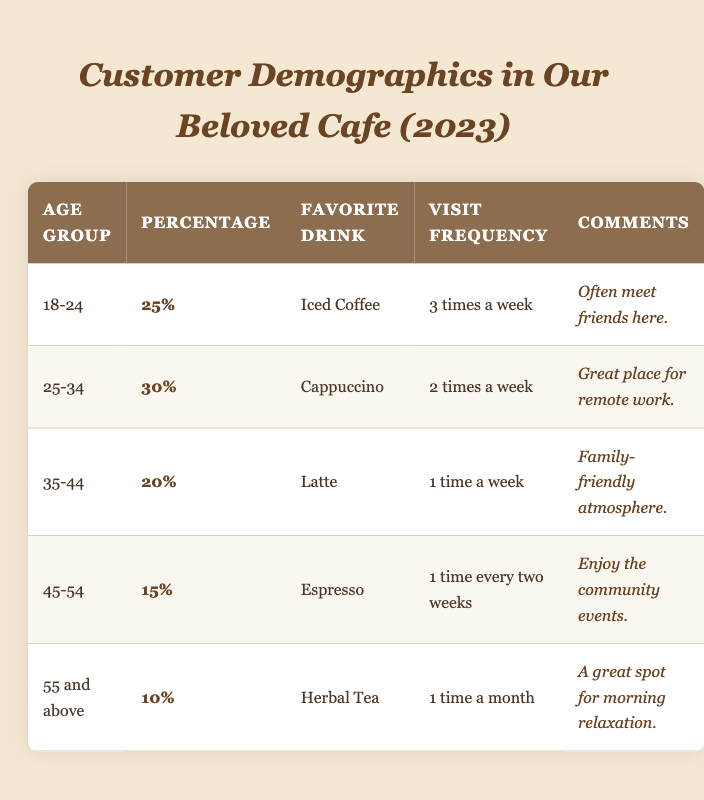What percentage of customers are aged 25-34? In the table, the entry for the age group 25-34 shows a percentage of 30%.
Answer: 30% Which age group visits the cafe most frequently? The age group 18-24 visits the cafe 3 times a week, which is more than any other group's frequency.
Answer: 18-24 What is the favorite drink of customers aged 55 and above? The table indicates that the favorite drink for the age group 55 and above is Herbal Tea.
Answer: Herbal Tea How many times do customers aged 35-44 visit the cafe in a month? Customers aged 35-44 visit the cafe 1 time a week. Thus, they visit 4 times in a month (1 time x 4 weeks).
Answer: 4 times What is the average percentage of customers from all age groups? To find the average, sum the percentages: 25% + 30% + 20% + 15% + 10% = 100%. Then divide by the number of age groups (5): 100% / 5 = 20%.
Answer: 20% Are more customers aged 18-24 or those aged 45-54? The percentage of customers aged 18-24 is 25%, while those aged 45-54 are 15%. Since 25% is greater than 15%, there are more customers aged 18-24.
Answer: Yes What is the total percentage of customers aged 35 and older? Add the percentages for age groups 35-44, 45-54, and 55 and above: 20% + 15% + 10% = 45%.
Answer: 45% Which age group enjoys the community events? The comments for the age group 45-54 state that they enjoy the community events.
Answer: 45-54 Which age group visits the cafe the least? The age group 55 and above visits the cafe the least, at a frequency of once a month.
Answer: 55 and above What is the percentage difference between the 25-34 age group and the 55 and above age group? The 25-34 age group has a percentage of 30% and the 55 and above age group has 10%. The percentage difference is 30% - 10% = 20%.
Answer: 20% 